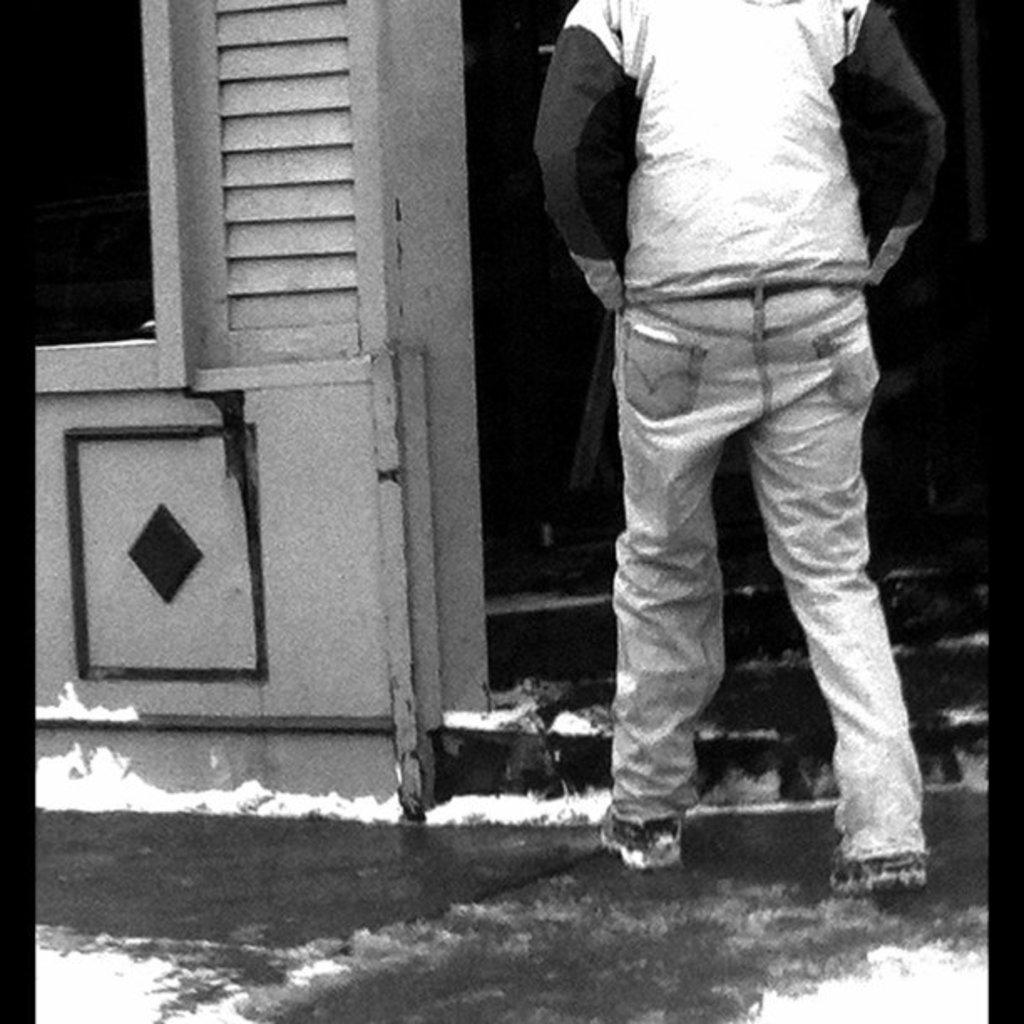What is the main subject of the image? There is a person standing in the front of the image. What can be seen in the background of the image? There are stairs visible in the background of the image. What is the color scheme of the image? The image is black and white in color. What type of farm animals can be seen in the image? There are no farm animals present in the image; it features a person standing in front of stairs in a black and white setting. 